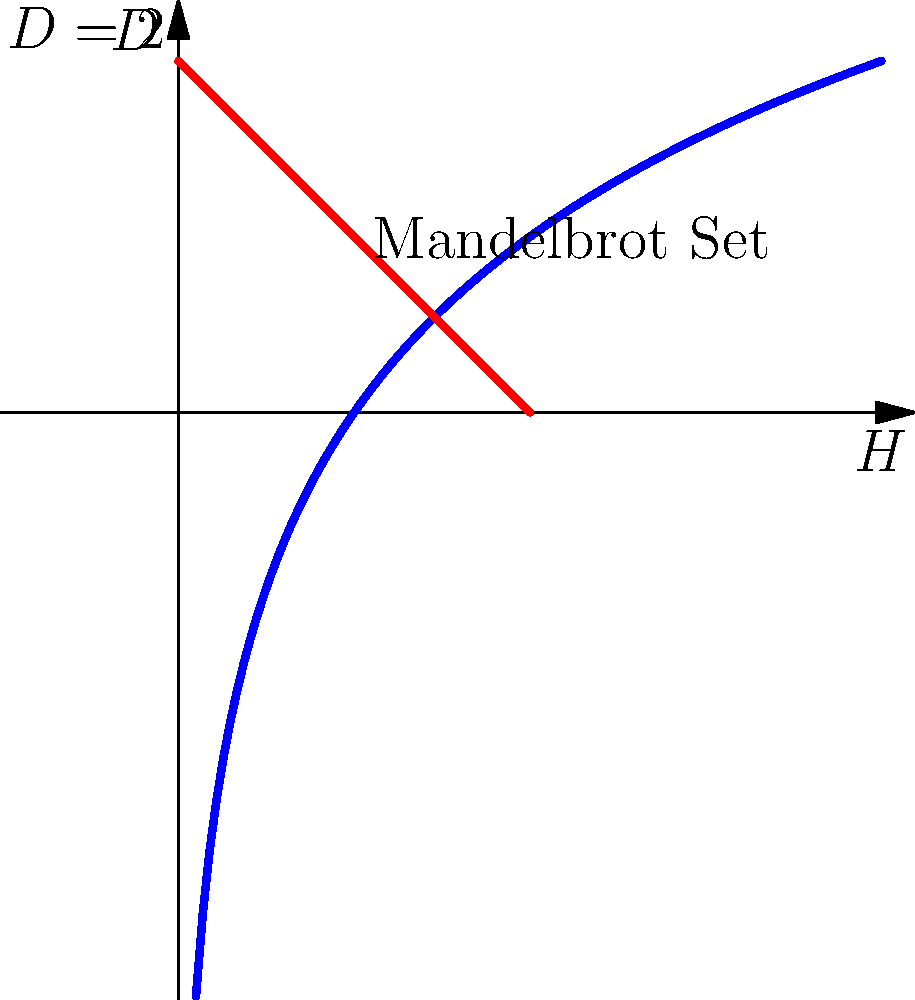In the context of fractal geometry and the spiritual symbolism of the Mandelbrot set, consider the graph above representing the relationship between the Hausdorff dimension (H) and the fractal dimension (D) of the Mandelbrot set's boundary. If the Hausdorff dimension of the Mandelbrot set's boundary is approximately 2, what is its fractal dimension? How might this relate to the concept of duality in spirituality? To calculate the fractal dimension of the Mandelbrot set's boundary, we need to understand the relationship between the Hausdorff dimension (H) and the fractal dimension (D). This relationship is given by the equation:

$$D = 2 - H$$

Where:
- D is the fractal dimension
- H is the Hausdorff dimension

Given that the Hausdorff dimension of the Mandelbrot set's boundary is approximately 2, we can substitute this value into the equation:

$$D = 2 - H$$
$$D = 2 - 2$$
$$D = 0$$

This result indicates that the fractal dimension of the Mandelbrot set's boundary is approximately 0.

From a spiritual perspective, this can be interpreted as follows:

1. The Mandelbrot set's boundary having a Hausdorff dimension of 2 suggests it fills the 2D plane, representing the material world or duality.

2. The fractal dimension being 0 can be seen as a point of singularity or unity, representing the spiritual realm or non-duality.

3. The coexistence of these dimensions (2 and 0) in the same object (Mandelbrot set) can be viewed as a symbol of the interconnectedness of the material and spiritual worlds, or the concept of "As above, so below" in mysticism.

4. The infinite complexity of the Mandelbrot set, despite its simple mathematical definition, can be seen as a metaphor for the profound depth and intricacy of spiritual truths hidden within seemingly simple concepts.

This interpretation allows for a unique blend of mathematical precision and spiritual symbolism, demonstrating how fractal geometry can serve as a bridge between scientific understanding and mystical exploration.
Answer: 0 